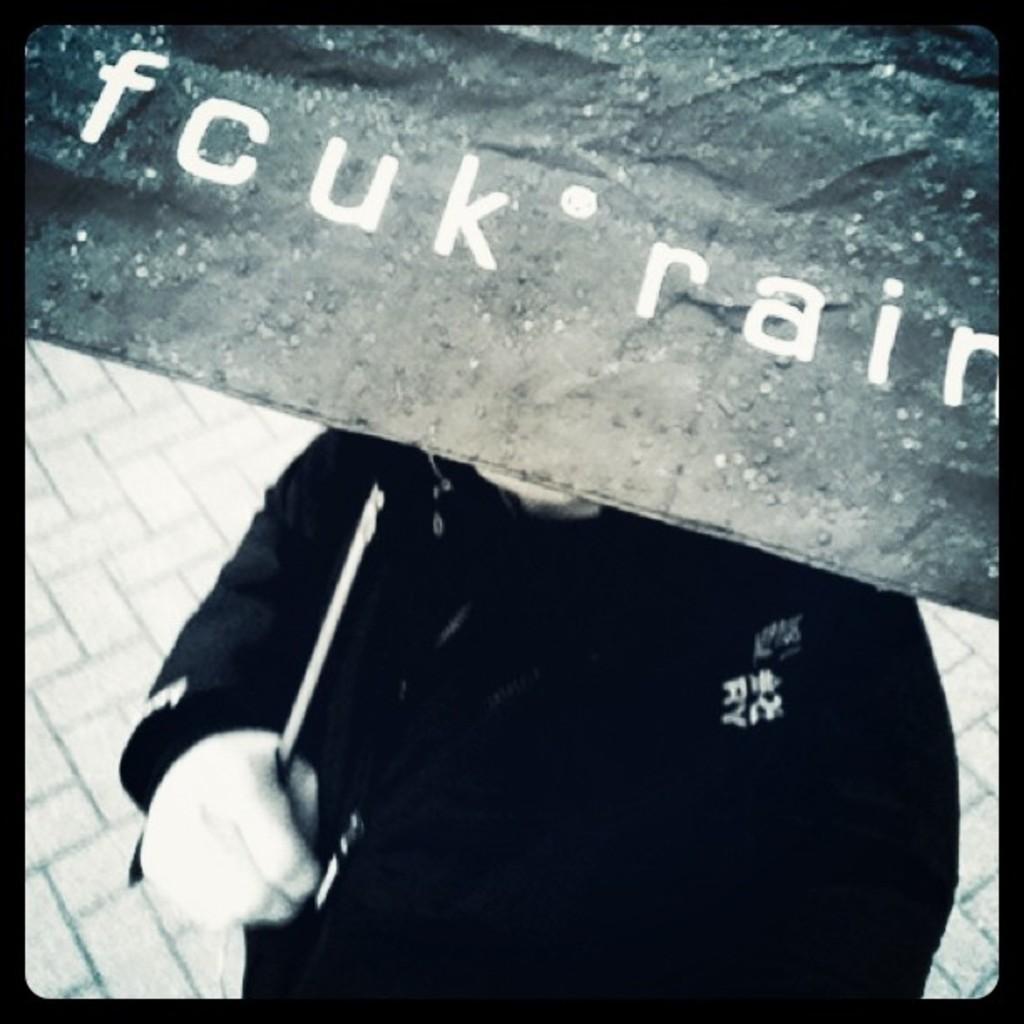What is the main subject of the image? There is a person in the image. What is the person holding in the image? The person is holding an umbrella. What is unique about the umbrella? The umbrella has text on it. What is the color scheme of the image? The image is black and white. What is visible at the bottom of the image? There is a floor visible at the bottom of the image. What type of property does the person own in the image? There is no indication of property ownership in the image; it only shows a person holding an umbrella. How does the person plan to expand their territory in the image? There is no indication of territorial expansion in the image; it only shows a person holding an umbrella. 